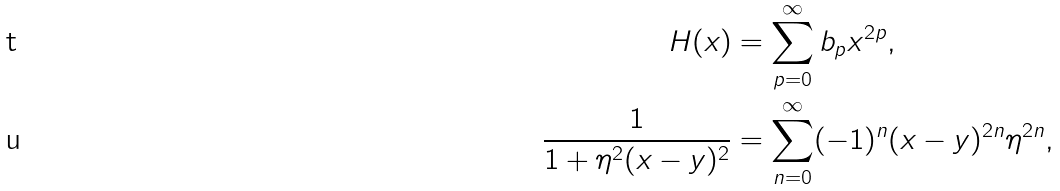Convert formula to latex. <formula><loc_0><loc_0><loc_500><loc_500>H ( x ) & = \sum _ { p = 0 } ^ { \infty } b _ { p } x ^ { 2 p } , \\ \frac { 1 } { 1 + \eta ^ { 2 } ( x - y ) ^ { 2 } } & = \sum _ { n = 0 } ^ { \infty } ( - 1 ) ^ { n } ( x - y ) ^ { 2 n } \eta ^ { 2 n } ,</formula> 